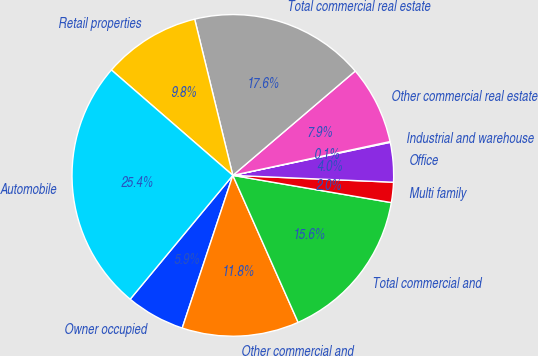Convert chart. <chart><loc_0><loc_0><loc_500><loc_500><pie_chart><fcel>Owner occupied<fcel>Other commercial and<fcel>Total commercial and<fcel>Multi family<fcel>Office<fcel>Industrial and warehouse<fcel>Other commercial real estate<fcel>Total commercial real estate<fcel>Retail properties<fcel>Automobile<nl><fcel>5.92%<fcel>11.75%<fcel>15.64%<fcel>2.03%<fcel>3.97%<fcel>0.08%<fcel>7.86%<fcel>17.58%<fcel>9.81%<fcel>25.36%<nl></chart> 